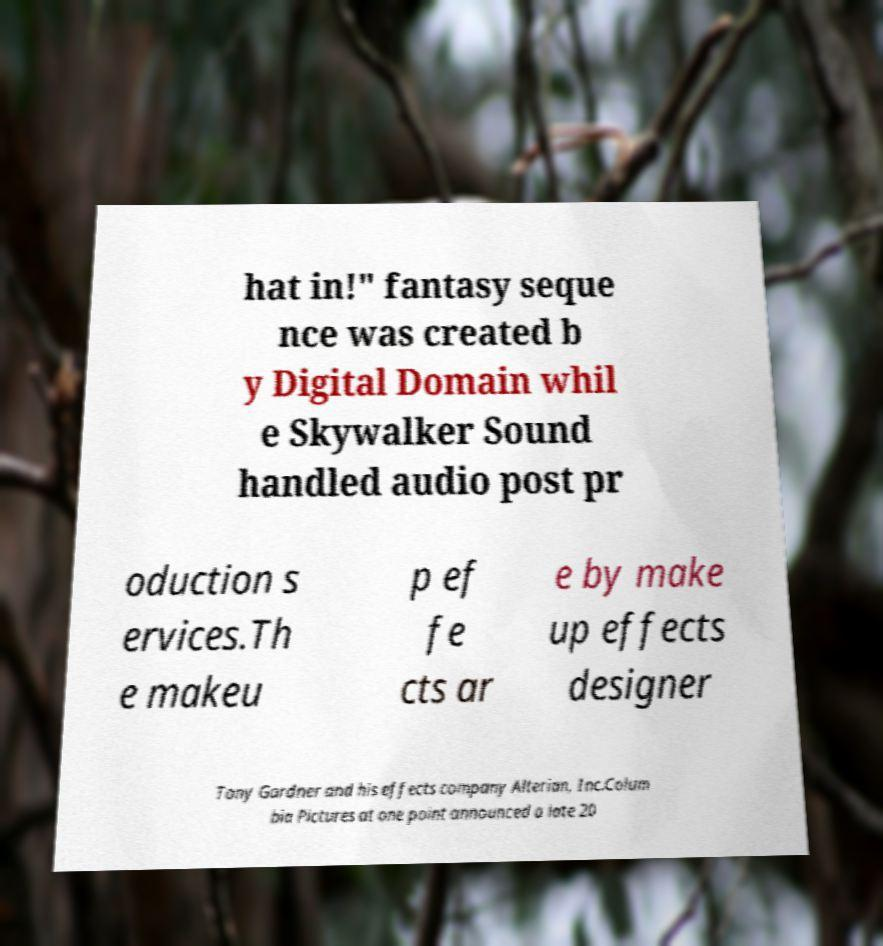For documentation purposes, I need the text within this image transcribed. Could you provide that? hat in!" fantasy seque nce was created b y Digital Domain whil e Skywalker Sound handled audio post pr oduction s ervices.Th e makeu p ef fe cts ar e by make up effects designer Tony Gardner and his effects company Alterian, Inc.Colum bia Pictures at one point announced a late 20 